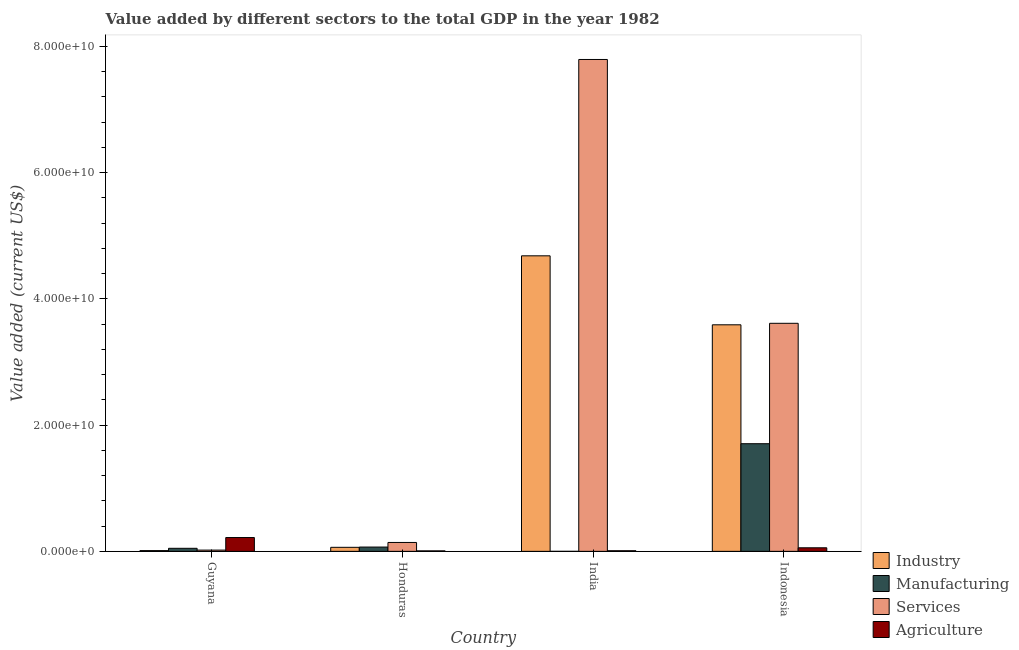How many different coloured bars are there?
Offer a terse response. 4. How many groups of bars are there?
Your answer should be compact. 4. Are the number of bars per tick equal to the number of legend labels?
Provide a succinct answer. Yes. Are the number of bars on each tick of the X-axis equal?
Offer a very short reply. Yes. How many bars are there on the 1st tick from the left?
Make the answer very short. 4. How many bars are there on the 2nd tick from the right?
Your answer should be very brief. 4. What is the label of the 1st group of bars from the left?
Give a very brief answer. Guyana. In how many cases, is the number of bars for a given country not equal to the number of legend labels?
Keep it short and to the point. 0. What is the value added by agricultural sector in Honduras?
Provide a short and direct response. 7.74e+07. Across all countries, what is the maximum value added by industrial sector?
Offer a terse response. 4.68e+1. Across all countries, what is the minimum value added by industrial sector?
Provide a short and direct response. 1.21e+08. In which country was the value added by agricultural sector maximum?
Your answer should be very brief. Guyana. In which country was the value added by services sector minimum?
Offer a terse response. Guyana. What is the total value added by industrial sector in the graph?
Your answer should be compact. 8.35e+1. What is the difference between the value added by services sector in Honduras and that in Indonesia?
Your answer should be very brief. -3.47e+1. What is the difference between the value added by services sector in Honduras and the value added by manufacturing sector in India?
Your response must be concise. 1.41e+09. What is the average value added by agricultural sector per country?
Keep it short and to the point. 7.33e+08. What is the difference between the value added by industrial sector and value added by agricultural sector in Honduras?
Your answer should be very brief. 5.62e+08. What is the ratio of the value added by services sector in Guyana to that in India?
Ensure brevity in your answer.  0. Is the difference between the value added by agricultural sector in Guyana and Indonesia greater than the difference between the value added by services sector in Guyana and Indonesia?
Ensure brevity in your answer.  Yes. What is the difference between the highest and the second highest value added by industrial sector?
Provide a short and direct response. 1.09e+1. What is the difference between the highest and the lowest value added by industrial sector?
Make the answer very short. 4.67e+1. In how many countries, is the value added by industrial sector greater than the average value added by industrial sector taken over all countries?
Offer a terse response. 2. Is the sum of the value added by manufacturing sector in Guyana and Honduras greater than the maximum value added by industrial sector across all countries?
Provide a short and direct response. No. Is it the case that in every country, the sum of the value added by manufacturing sector and value added by agricultural sector is greater than the sum of value added by industrial sector and value added by services sector?
Your answer should be very brief. No. What does the 2nd bar from the left in India represents?
Offer a terse response. Manufacturing. What does the 3rd bar from the right in Indonesia represents?
Ensure brevity in your answer.  Manufacturing. How many bars are there?
Your answer should be compact. 16. Are all the bars in the graph horizontal?
Offer a terse response. No. What is the difference between two consecutive major ticks on the Y-axis?
Make the answer very short. 2.00e+1. Does the graph contain any zero values?
Offer a terse response. No. Does the graph contain grids?
Provide a short and direct response. No. Where does the legend appear in the graph?
Your answer should be very brief. Bottom right. What is the title of the graph?
Offer a very short reply. Value added by different sectors to the total GDP in the year 1982. What is the label or title of the X-axis?
Ensure brevity in your answer.  Country. What is the label or title of the Y-axis?
Offer a very short reply. Value added (current US$). What is the Value added (current US$) of Industry in Guyana?
Keep it short and to the point. 1.21e+08. What is the Value added (current US$) in Manufacturing in Guyana?
Offer a terse response. 4.84e+08. What is the Value added (current US$) in Services in Guyana?
Offer a very short reply. 1.99e+08. What is the Value added (current US$) in Agriculture in Guyana?
Make the answer very short. 2.19e+09. What is the Value added (current US$) in Industry in Honduras?
Make the answer very short. 6.39e+08. What is the Value added (current US$) in Manufacturing in Honduras?
Ensure brevity in your answer.  6.82e+08. What is the Value added (current US$) in Services in Honduras?
Provide a short and direct response. 1.41e+09. What is the Value added (current US$) of Agriculture in Honduras?
Make the answer very short. 7.74e+07. What is the Value added (current US$) of Industry in India?
Provide a short and direct response. 4.68e+1. What is the Value added (current US$) of Manufacturing in India?
Offer a very short reply. 5.80e+05. What is the Value added (current US$) of Services in India?
Keep it short and to the point. 7.79e+1. What is the Value added (current US$) in Agriculture in India?
Make the answer very short. 9.73e+07. What is the Value added (current US$) in Industry in Indonesia?
Offer a terse response. 3.59e+1. What is the Value added (current US$) of Manufacturing in Indonesia?
Your answer should be compact. 1.71e+1. What is the Value added (current US$) in Services in Indonesia?
Make the answer very short. 3.61e+1. What is the Value added (current US$) of Agriculture in Indonesia?
Your answer should be very brief. 5.66e+08. Across all countries, what is the maximum Value added (current US$) in Industry?
Make the answer very short. 4.68e+1. Across all countries, what is the maximum Value added (current US$) of Manufacturing?
Your answer should be compact. 1.71e+1. Across all countries, what is the maximum Value added (current US$) in Services?
Give a very brief answer. 7.79e+1. Across all countries, what is the maximum Value added (current US$) of Agriculture?
Provide a short and direct response. 2.19e+09. Across all countries, what is the minimum Value added (current US$) in Industry?
Give a very brief answer. 1.21e+08. Across all countries, what is the minimum Value added (current US$) in Manufacturing?
Make the answer very short. 5.80e+05. Across all countries, what is the minimum Value added (current US$) of Services?
Your answer should be compact. 1.99e+08. Across all countries, what is the minimum Value added (current US$) of Agriculture?
Make the answer very short. 7.74e+07. What is the total Value added (current US$) of Industry in the graph?
Provide a succinct answer. 8.35e+1. What is the total Value added (current US$) of Manufacturing in the graph?
Keep it short and to the point. 1.82e+1. What is the total Value added (current US$) in Services in the graph?
Offer a terse response. 1.16e+11. What is the total Value added (current US$) in Agriculture in the graph?
Provide a succinct answer. 2.93e+09. What is the difference between the Value added (current US$) of Industry in Guyana and that in Honduras?
Offer a very short reply. -5.18e+08. What is the difference between the Value added (current US$) of Manufacturing in Guyana and that in Honduras?
Ensure brevity in your answer.  -1.97e+08. What is the difference between the Value added (current US$) in Services in Guyana and that in Honduras?
Your answer should be very brief. -1.21e+09. What is the difference between the Value added (current US$) of Agriculture in Guyana and that in Honduras?
Provide a succinct answer. 2.11e+09. What is the difference between the Value added (current US$) of Industry in Guyana and that in India?
Your answer should be compact. -4.67e+1. What is the difference between the Value added (current US$) of Manufacturing in Guyana and that in India?
Provide a succinct answer. 4.84e+08. What is the difference between the Value added (current US$) in Services in Guyana and that in India?
Provide a succinct answer. -7.77e+1. What is the difference between the Value added (current US$) in Agriculture in Guyana and that in India?
Give a very brief answer. 2.09e+09. What is the difference between the Value added (current US$) in Industry in Guyana and that in Indonesia?
Your answer should be compact. -3.58e+1. What is the difference between the Value added (current US$) of Manufacturing in Guyana and that in Indonesia?
Keep it short and to the point. -1.66e+1. What is the difference between the Value added (current US$) of Services in Guyana and that in Indonesia?
Offer a terse response. -3.59e+1. What is the difference between the Value added (current US$) of Agriculture in Guyana and that in Indonesia?
Ensure brevity in your answer.  1.62e+09. What is the difference between the Value added (current US$) of Industry in Honduras and that in India?
Provide a succinct answer. -4.62e+1. What is the difference between the Value added (current US$) of Manufacturing in Honduras and that in India?
Provide a succinct answer. 6.81e+08. What is the difference between the Value added (current US$) of Services in Honduras and that in India?
Your answer should be very brief. -7.65e+1. What is the difference between the Value added (current US$) of Agriculture in Honduras and that in India?
Make the answer very short. -1.99e+07. What is the difference between the Value added (current US$) in Industry in Honduras and that in Indonesia?
Provide a short and direct response. -3.53e+1. What is the difference between the Value added (current US$) of Manufacturing in Honduras and that in Indonesia?
Provide a succinct answer. -1.64e+1. What is the difference between the Value added (current US$) in Services in Honduras and that in Indonesia?
Make the answer very short. -3.47e+1. What is the difference between the Value added (current US$) of Agriculture in Honduras and that in Indonesia?
Offer a terse response. -4.89e+08. What is the difference between the Value added (current US$) of Industry in India and that in Indonesia?
Offer a terse response. 1.09e+1. What is the difference between the Value added (current US$) in Manufacturing in India and that in Indonesia?
Provide a succinct answer. -1.71e+1. What is the difference between the Value added (current US$) in Services in India and that in Indonesia?
Your response must be concise. 4.18e+1. What is the difference between the Value added (current US$) in Agriculture in India and that in Indonesia?
Your response must be concise. -4.69e+08. What is the difference between the Value added (current US$) in Industry in Guyana and the Value added (current US$) in Manufacturing in Honduras?
Provide a succinct answer. -5.61e+08. What is the difference between the Value added (current US$) of Industry in Guyana and the Value added (current US$) of Services in Honduras?
Your response must be concise. -1.29e+09. What is the difference between the Value added (current US$) of Industry in Guyana and the Value added (current US$) of Agriculture in Honduras?
Make the answer very short. 4.33e+07. What is the difference between the Value added (current US$) of Manufacturing in Guyana and the Value added (current US$) of Services in Honduras?
Provide a short and direct response. -9.26e+08. What is the difference between the Value added (current US$) in Manufacturing in Guyana and the Value added (current US$) in Agriculture in Honduras?
Ensure brevity in your answer.  4.07e+08. What is the difference between the Value added (current US$) in Services in Guyana and the Value added (current US$) in Agriculture in Honduras?
Give a very brief answer. 1.21e+08. What is the difference between the Value added (current US$) of Industry in Guyana and the Value added (current US$) of Manufacturing in India?
Provide a short and direct response. 1.20e+08. What is the difference between the Value added (current US$) of Industry in Guyana and the Value added (current US$) of Services in India?
Your response must be concise. -7.78e+1. What is the difference between the Value added (current US$) of Industry in Guyana and the Value added (current US$) of Agriculture in India?
Your answer should be very brief. 2.33e+07. What is the difference between the Value added (current US$) in Manufacturing in Guyana and the Value added (current US$) in Services in India?
Ensure brevity in your answer.  -7.75e+1. What is the difference between the Value added (current US$) in Manufacturing in Guyana and the Value added (current US$) in Agriculture in India?
Your answer should be very brief. 3.87e+08. What is the difference between the Value added (current US$) of Services in Guyana and the Value added (current US$) of Agriculture in India?
Make the answer very short. 1.01e+08. What is the difference between the Value added (current US$) in Industry in Guyana and the Value added (current US$) in Manufacturing in Indonesia?
Your response must be concise. -1.69e+1. What is the difference between the Value added (current US$) in Industry in Guyana and the Value added (current US$) in Services in Indonesia?
Provide a succinct answer. -3.60e+1. What is the difference between the Value added (current US$) in Industry in Guyana and the Value added (current US$) in Agriculture in Indonesia?
Your answer should be very brief. -4.45e+08. What is the difference between the Value added (current US$) in Manufacturing in Guyana and the Value added (current US$) in Services in Indonesia?
Offer a terse response. -3.57e+1. What is the difference between the Value added (current US$) of Manufacturing in Guyana and the Value added (current US$) of Agriculture in Indonesia?
Your response must be concise. -8.17e+07. What is the difference between the Value added (current US$) of Services in Guyana and the Value added (current US$) of Agriculture in Indonesia?
Provide a short and direct response. -3.67e+08. What is the difference between the Value added (current US$) of Industry in Honduras and the Value added (current US$) of Manufacturing in India?
Provide a succinct answer. 6.38e+08. What is the difference between the Value added (current US$) in Industry in Honduras and the Value added (current US$) in Services in India?
Give a very brief answer. -7.73e+1. What is the difference between the Value added (current US$) of Industry in Honduras and the Value added (current US$) of Agriculture in India?
Your response must be concise. 5.42e+08. What is the difference between the Value added (current US$) of Manufacturing in Honduras and the Value added (current US$) of Services in India?
Your response must be concise. -7.73e+1. What is the difference between the Value added (current US$) of Manufacturing in Honduras and the Value added (current US$) of Agriculture in India?
Make the answer very short. 5.84e+08. What is the difference between the Value added (current US$) of Services in Honduras and the Value added (current US$) of Agriculture in India?
Make the answer very short. 1.31e+09. What is the difference between the Value added (current US$) in Industry in Honduras and the Value added (current US$) in Manufacturing in Indonesia?
Give a very brief answer. -1.64e+1. What is the difference between the Value added (current US$) of Industry in Honduras and the Value added (current US$) of Services in Indonesia?
Ensure brevity in your answer.  -3.55e+1. What is the difference between the Value added (current US$) of Industry in Honduras and the Value added (current US$) of Agriculture in Indonesia?
Provide a succinct answer. 7.30e+07. What is the difference between the Value added (current US$) in Manufacturing in Honduras and the Value added (current US$) in Services in Indonesia?
Offer a terse response. -3.55e+1. What is the difference between the Value added (current US$) of Manufacturing in Honduras and the Value added (current US$) of Agriculture in Indonesia?
Your answer should be very brief. 1.16e+08. What is the difference between the Value added (current US$) of Services in Honduras and the Value added (current US$) of Agriculture in Indonesia?
Make the answer very short. 8.45e+08. What is the difference between the Value added (current US$) in Industry in India and the Value added (current US$) in Manufacturing in Indonesia?
Your answer should be compact. 2.98e+1. What is the difference between the Value added (current US$) of Industry in India and the Value added (current US$) of Services in Indonesia?
Provide a succinct answer. 1.07e+1. What is the difference between the Value added (current US$) of Industry in India and the Value added (current US$) of Agriculture in Indonesia?
Keep it short and to the point. 4.63e+1. What is the difference between the Value added (current US$) in Manufacturing in India and the Value added (current US$) in Services in Indonesia?
Make the answer very short. -3.61e+1. What is the difference between the Value added (current US$) of Manufacturing in India and the Value added (current US$) of Agriculture in Indonesia?
Offer a very short reply. -5.65e+08. What is the difference between the Value added (current US$) of Services in India and the Value added (current US$) of Agriculture in Indonesia?
Your answer should be very brief. 7.74e+1. What is the average Value added (current US$) in Industry per country?
Provide a succinct answer. 2.09e+1. What is the average Value added (current US$) in Manufacturing per country?
Offer a terse response. 4.56e+09. What is the average Value added (current US$) of Services per country?
Provide a succinct answer. 2.89e+1. What is the average Value added (current US$) in Agriculture per country?
Your response must be concise. 7.33e+08. What is the difference between the Value added (current US$) of Industry and Value added (current US$) of Manufacturing in Guyana?
Your answer should be compact. -3.64e+08. What is the difference between the Value added (current US$) in Industry and Value added (current US$) in Services in Guyana?
Keep it short and to the point. -7.80e+07. What is the difference between the Value added (current US$) of Industry and Value added (current US$) of Agriculture in Guyana?
Make the answer very short. -2.07e+09. What is the difference between the Value added (current US$) in Manufacturing and Value added (current US$) in Services in Guyana?
Your answer should be compact. 2.86e+08. What is the difference between the Value added (current US$) of Manufacturing and Value added (current US$) of Agriculture in Guyana?
Provide a short and direct response. -1.71e+09. What is the difference between the Value added (current US$) of Services and Value added (current US$) of Agriculture in Guyana?
Provide a succinct answer. -1.99e+09. What is the difference between the Value added (current US$) of Industry and Value added (current US$) of Manufacturing in Honduras?
Your answer should be compact. -4.28e+07. What is the difference between the Value added (current US$) in Industry and Value added (current US$) in Services in Honduras?
Offer a very short reply. -7.72e+08. What is the difference between the Value added (current US$) of Industry and Value added (current US$) of Agriculture in Honduras?
Provide a succinct answer. 5.62e+08. What is the difference between the Value added (current US$) of Manufacturing and Value added (current US$) of Services in Honduras?
Keep it short and to the point. -7.29e+08. What is the difference between the Value added (current US$) of Manufacturing and Value added (current US$) of Agriculture in Honduras?
Your answer should be compact. 6.04e+08. What is the difference between the Value added (current US$) of Services and Value added (current US$) of Agriculture in Honduras?
Keep it short and to the point. 1.33e+09. What is the difference between the Value added (current US$) in Industry and Value added (current US$) in Manufacturing in India?
Your response must be concise. 4.68e+1. What is the difference between the Value added (current US$) in Industry and Value added (current US$) in Services in India?
Your answer should be compact. -3.11e+1. What is the difference between the Value added (current US$) of Industry and Value added (current US$) of Agriculture in India?
Your response must be concise. 4.67e+1. What is the difference between the Value added (current US$) of Manufacturing and Value added (current US$) of Services in India?
Your answer should be compact. -7.79e+1. What is the difference between the Value added (current US$) in Manufacturing and Value added (current US$) in Agriculture in India?
Offer a very short reply. -9.68e+07. What is the difference between the Value added (current US$) of Services and Value added (current US$) of Agriculture in India?
Your response must be concise. 7.78e+1. What is the difference between the Value added (current US$) of Industry and Value added (current US$) of Manufacturing in Indonesia?
Offer a terse response. 1.88e+1. What is the difference between the Value added (current US$) in Industry and Value added (current US$) in Services in Indonesia?
Offer a terse response. -2.36e+08. What is the difference between the Value added (current US$) of Industry and Value added (current US$) of Agriculture in Indonesia?
Make the answer very short. 3.53e+1. What is the difference between the Value added (current US$) in Manufacturing and Value added (current US$) in Services in Indonesia?
Ensure brevity in your answer.  -1.91e+1. What is the difference between the Value added (current US$) of Manufacturing and Value added (current US$) of Agriculture in Indonesia?
Offer a terse response. 1.65e+1. What is the difference between the Value added (current US$) of Services and Value added (current US$) of Agriculture in Indonesia?
Provide a short and direct response. 3.56e+1. What is the ratio of the Value added (current US$) in Industry in Guyana to that in Honduras?
Ensure brevity in your answer.  0.19. What is the ratio of the Value added (current US$) of Manufacturing in Guyana to that in Honduras?
Keep it short and to the point. 0.71. What is the ratio of the Value added (current US$) in Services in Guyana to that in Honduras?
Provide a succinct answer. 0.14. What is the ratio of the Value added (current US$) in Agriculture in Guyana to that in Honduras?
Make the answer very short. 28.3. What is the ratio of the Value added (current US$) of Industry in Guyana to that in India?
Offer a very short reply. 0. What is the ratio of the Value added (current US$) of Manufacturing in Guyana to that in India?
Provide a short and direct response. 834.68. What is the ratio of the Value added (current US$) in Services in Guyana to that in India?
Your answer should be very brief. 0. What is the ratio of the Value added (current US$) in Agriculture in Guyana to that in India?
Keep it short and to the point. 22.5. What is the ratio of the Value added (current US$) in Industry in Guyana to that in Indonesia?
Offer a very short reply. 0. What is the ratio of the Value added (current US$) of Manufacturing in Guyana to that in Indonesia?
Your answer should be very brief. 0.03. What is the ratio of the Value added (current US$) in Services in Guyana to that in Indonesia?
Your answer should be very brief. 0.01. What is the ratio of the Value added (current US$) of Agriculture in Guyana to that in Indonesia?
Provide a short and direct response. 3.87. What is the ratio of the Value added (current US$) of Industry in Honduras to that in India?
Ensure brevity in your answer.  0.01. What is the ratio of the Value added (current US$) in Manufacturing in Honduras to that in India?
Your answer should be very brief. 1175.08. What is the ratio of the Value added (current US$) of Services in Honduras to that in India?
Offer a terse response. 0.02. What is the ratio of the Value added (current US$) in Agriculture in Honduras to that in India?
Offer a terse response. 0.8. What is the ratio of the Value added (current US$) of Industry in Honduras to that in Indonesia?
Your response must be concise. 0.02. What is the ratio of the Value added (current US$) in Manufacturing in Honduras to that in Indonesia?
Make the answer very short. 0.04. What is the ratio of the Value added (current US$) in Services in Honduras to that in Indonesia?
Your answer should be compact. 0.04. What is the ratio of the Value added (current US$) of Agriculture in Honduras to that in Indonesia?
Make the answer very short. 0.14. What is the ratio of the Value added (current US$) in Industry in India to that in Indonesia?
Keep it short and to the point. 1.3. What is the ratio of the Value added (current US$) in Services in India to that in Indonesia?
Provide a short and direct response. 2.16. What is the ratio of the Value added (current US$) in Agriculture in India to that in Indonesia?
Ensure brevity in your answer.  0.17. What is the difference between the highest and the second highest Value added (current US$) of Industry?
Ensure brevity in your answer.  1.09e+1. What is the difference between the highest and the second highest Value added (current US$) of Manufacturing?
Provide a short and direct response. 1.64e+1. What is the difference between the highest and the second highest Value added (current US$) of Services?
Keep it short and to the point. 4.18e+1. What is the difference between the highest and the second highest Value added (current US$) in Agriculture?
Provide a short and direct response. 1.62e+09. What is the difference between the highest and the lowest Value added (current US$) of Industry?
Keep it short and to the point. 4.67e+1. What is the difference between the highest and the lowest Value added (current US$) of Manufacturing?
Offer a very short reply. 1.71e+1. What is the difference between the highest and the lowest Value added (current US$) of Services?
Provide a succinct answer. 7.77e+1. What is the difference between the highest and the lowest Value added (current US$) of Agriculture?
Your response must be concise. 2.11e+09. 